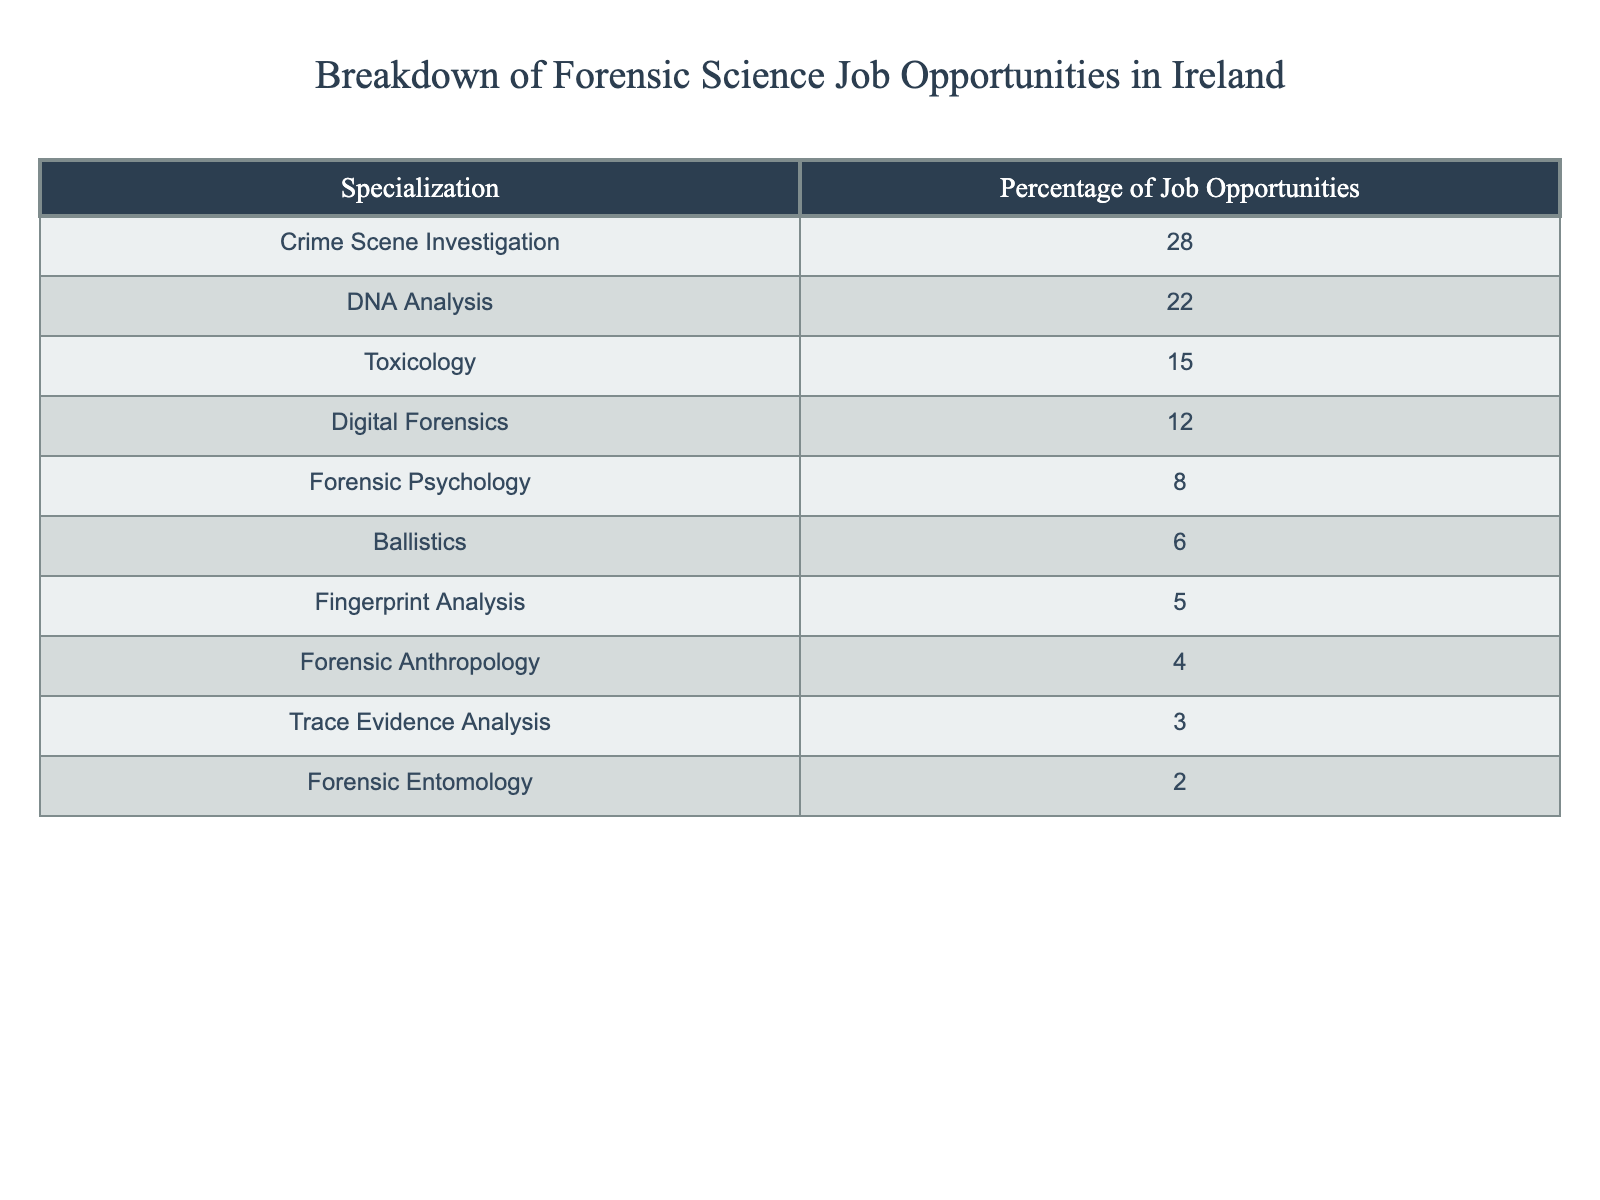What percentage of job opportunities is dedicated to Crime Scene Investigation? The table shows that Crime Scene Investigation has a percentage of 28% for job opportunities.
Answer: 28% Which specialization has the least percentage of job opportunities? According to the table, Forensic Entomology has the least percentage of job opportunities at 2%.
Answer: 2% What is the combined percentage of job opportunities for Forensic Psychology and Fingerprint Analysis? Forensic Psychology has 8% and Fingerprint Analysis has 5%. Adding these percentages together: 8% + 5% = 13%.
Answer: 13% Is Digital Forensics among the top three specializations for job opportunities? The table shows that Digital Forensics accounts for 12%, which is not in the top three specializations (Crime Scene Investigation, DNA Analysis, and Toxicology). Thus, the answer is no.
Answer: No What is the difference in job opportunities percentage between DNA Analysis and Toxicology? DNA Analysis represents 22% and Toxicology is 15%. To find the difference, subtract the percentage of Toxicology from DNA Analysis: 22% - 15% = 7%.
Answer: 7% If you combine the percentages of Trace Evidence Analysis and Forensic Anthropology, what is the total? Trace Evidence Analysis is 3% and Forensic Anthropology is 4%. Adding these percentages gives: 3% + 4% = 7%.
Answer: 7% What is the average percentage of job opportunities across all specializations mentioned? To calculate the average, sum all percentages: 28 + 22 + 15 + 12 + 8 + 6 + 5 + 4 + 3 + 2 = 105. There are 10 specializations, so the average is 105 / 10 = 10.5%.
Answer: 10.5% If you were to rank the specializations, which one comes in fourth place? The rankings by percentage are as follows: 1) Crime Scene Investigation (28%), 2) DNA Analysis (22%), 3) Toxicology (15%), and 4) Digital Forensics (12%).
Answer: Digital Forensics How much percentage difference exists between the highest and lowest specialization? The highest is Crime Scene Investigation at 28%, and the lowest is Forensic Entomology at 2%. Calculating the difference gives: 28% - 2% = 26%.
Answer: 26% Which two specializations combined have a percentage of greater than 30%? Crime Scene Investigation (28%) and DNA Analysis (22%) total 50%, which is greater than 30%. However, no other combination meets that criteria.
Answer: Crime Scene Investigation and DNA Analysis 